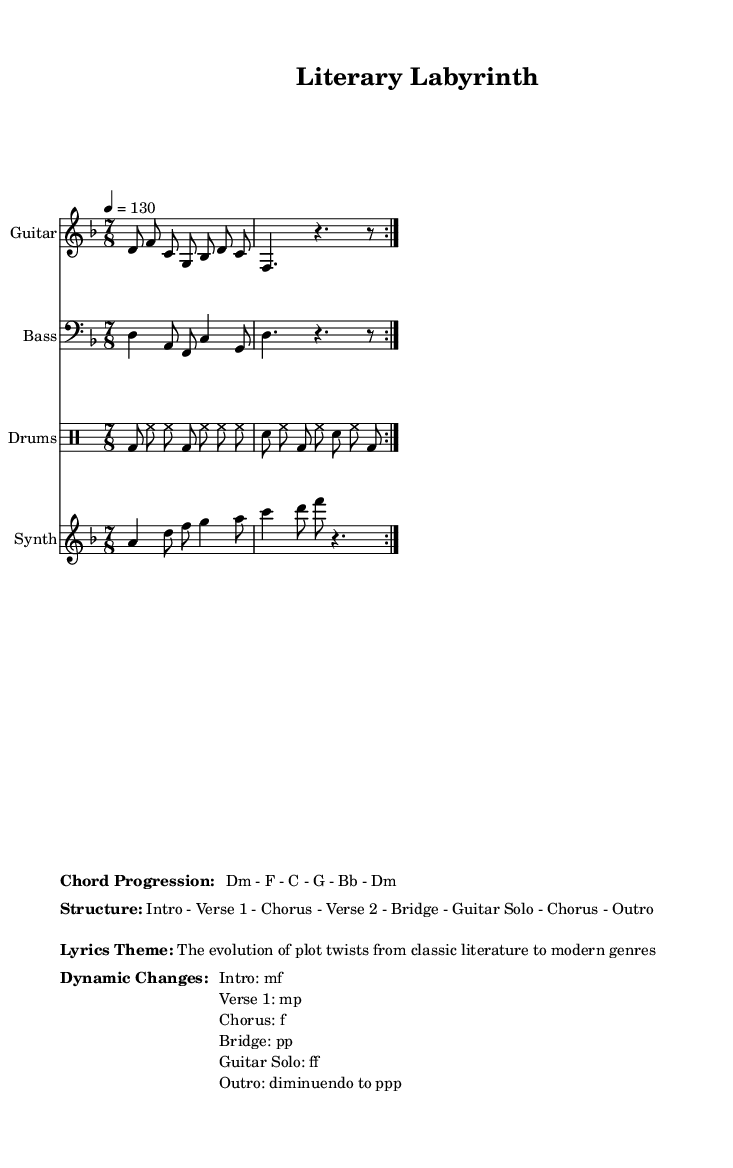What is the key signature of this music? The key signature is D minor, as indicated at the beginning of the score. D minor has one flat (B-flat), which is consistent with the musical phrases.
Answer: D minor What is the time signature of this music? The time signature is 7/8, which indicates that there are seven eighth notes per measure. This can be seen at the beginning of the sheet music.
Answer: 7/8 What is the tempo marking of this composition? The tempo marking is given as "4 = 130," which means there should be 130 quarter note beats per minute. This is indicated next to the time signature.
Answer: 130 How many volta sections are in the guitar riff? The guitar riff has two volta sections, which are indicated by the repeat markings (volta 2) that suggest playing the section twice.
Answer: 2 What is the dynamic mark for the bridge section? The dynamic mark for the bridge section is "pp," meaning pianissimo, or very soft. This is specified in the dynamic changes of the markup.
Answer: pp What is the thematic focus of the lyrics? The thematic focus of the lyrics is "The evolution of plot twists from classic literature to modern genres," as outlined in the markup section of the sheet music.
Answer: The evolution of plot twists from classic literature to modern genres Which section of the composition features a guitar solo? The guitar solo is specified after the bridge section, indicating a distinct part dedicated to the guitar within the structure.
Answer: Guitar Solo 